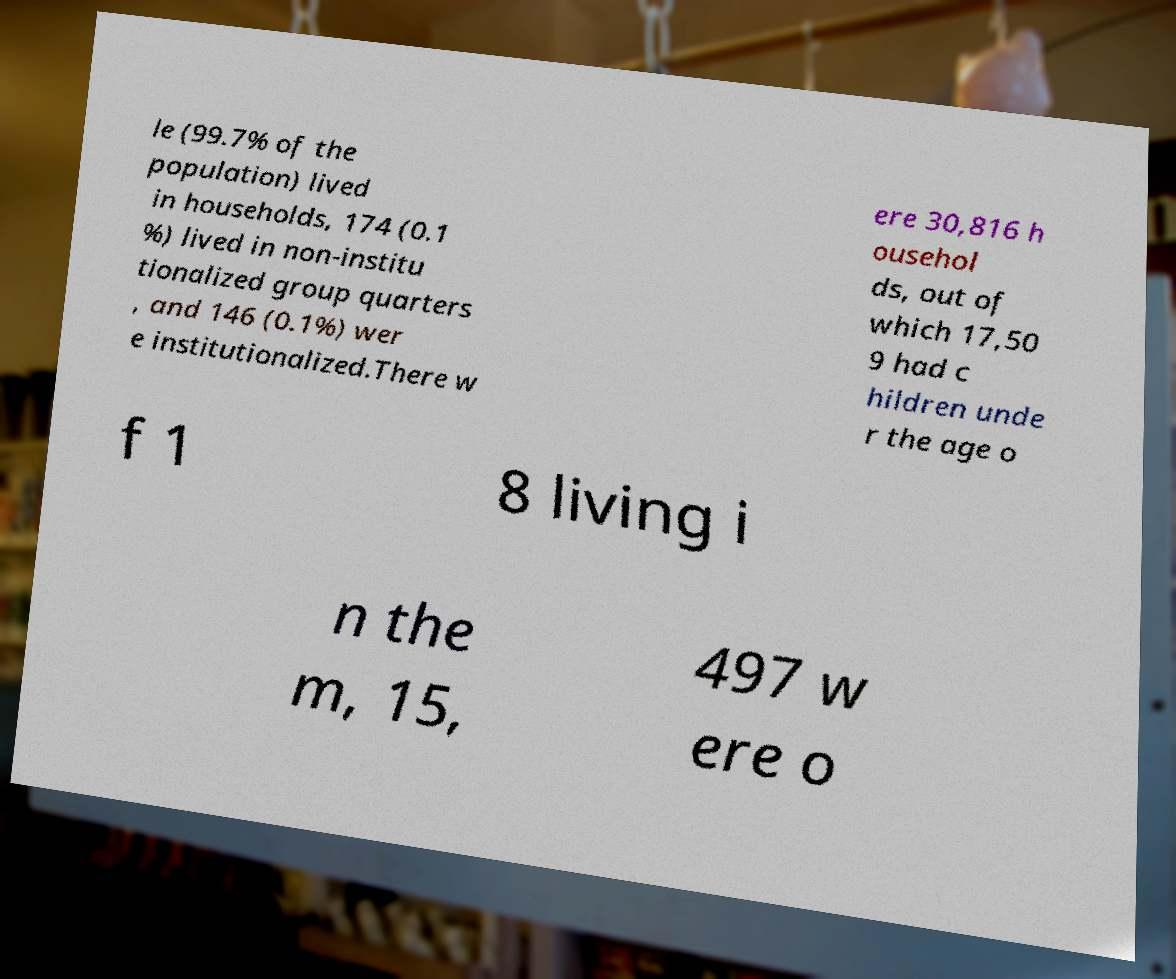Could you extract and type out the text from this image? le (99.7% of the population) lived in households, 174 (0.1 %) lived in non-institu tionalized group quarters , and 146 (0.1%) wer e institutionalized.There w ere 30,816 h ousehol ds, out of which 17,50 9 had c hildren unde r the age o f 1 8 living i n the m, 15, 497 w ere o 